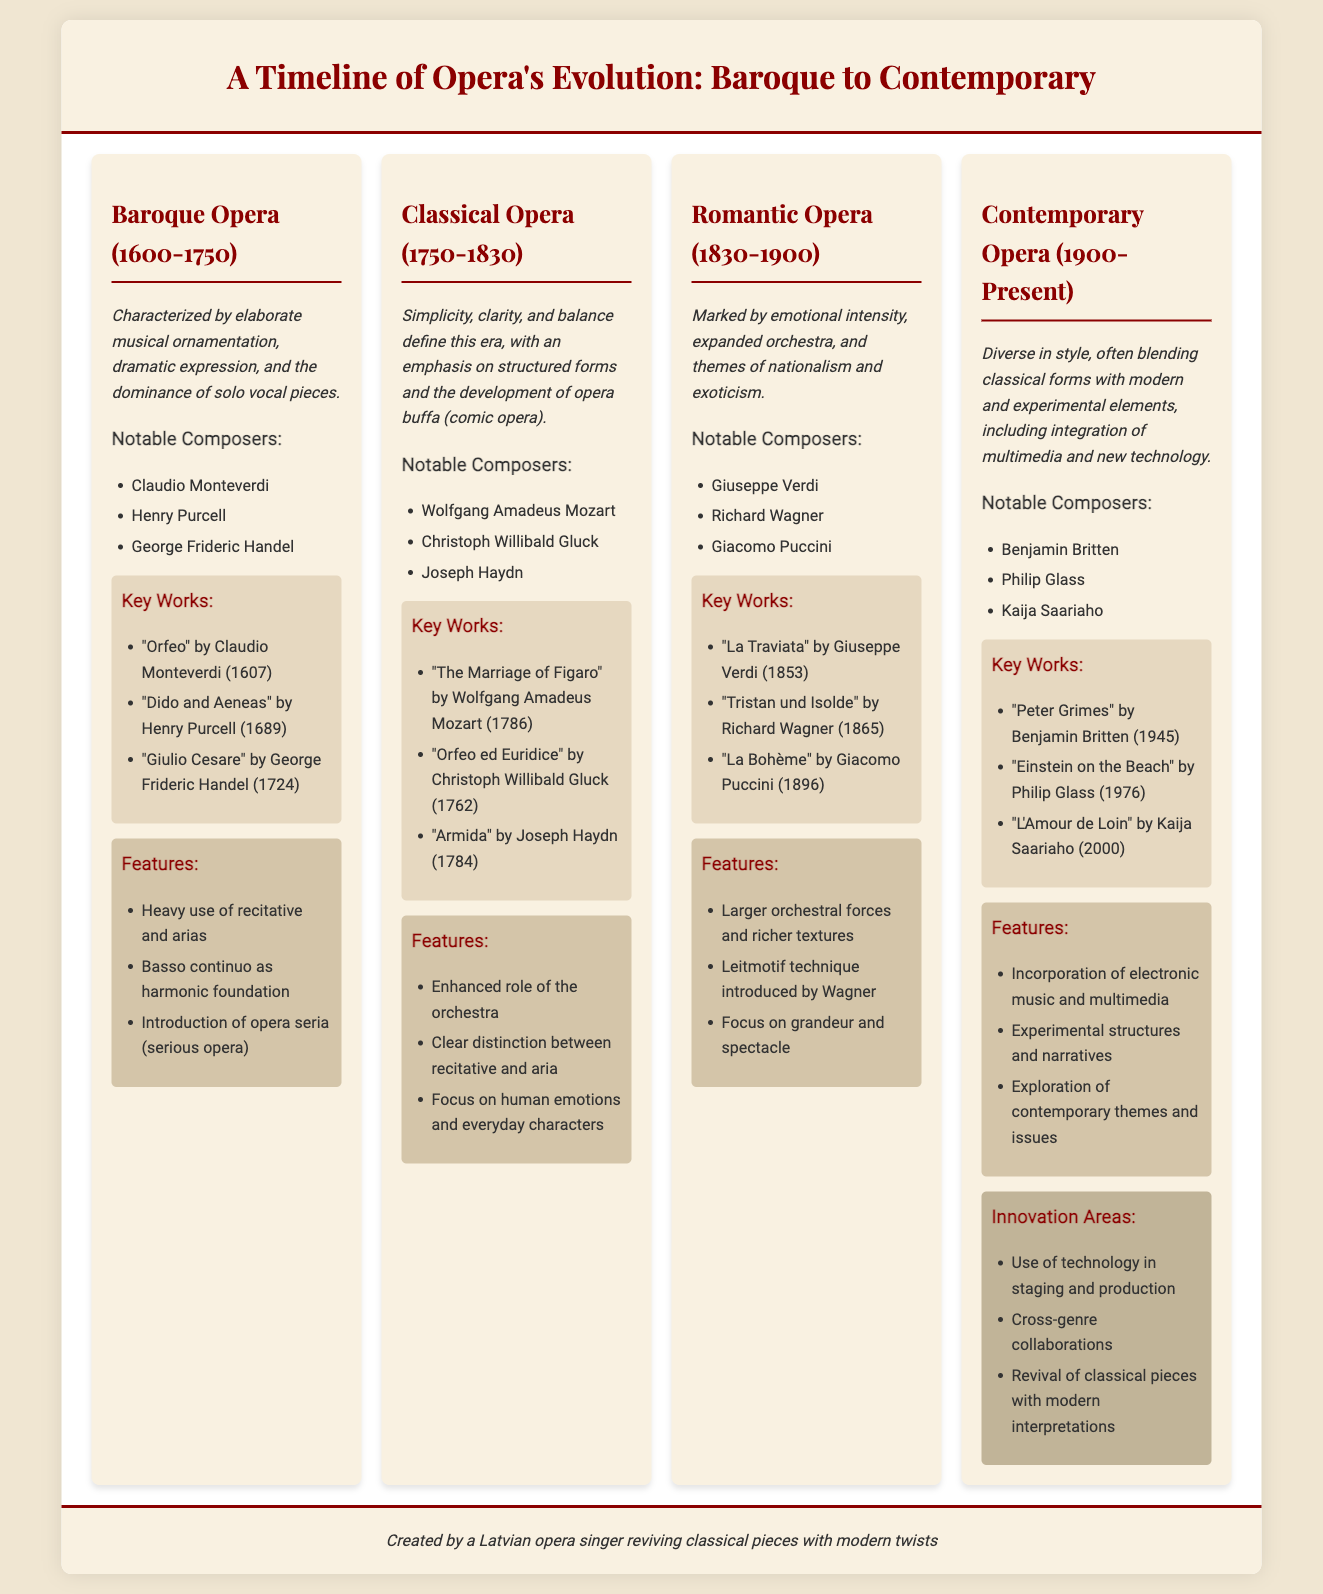What are the years of the Baroque Opera era? The Baroque Opera era is defined by the years 1600 to 1750 as stated in the document.
Answer: 1600-1750 Who composed "La Traviata"? "La Traviata" is attributed to Giuseppe Verdi according to the key works listed in the document.
Answer: Giuseppe Verdi Which style is characterized by emotional intensity and themes of nationalism? The Romantic Opera era is marked by emotional intensity and themes of nationalism as described in the document.
Answer: Romantic Opera What notable composer is associated with the Contemporary Opera era? William Philip Glass is listed as a notable composer for the Contemporary Opera era in the document.
Answer: Philip Glass How many key works are listed for Classical Opera? There are three key works mentioned for the Classical Opera era, which can be counted from the key works section.
Answer: 3 Which innovation areas are mentioned in the Contemporary Opera section? The innovation areas include technology use in staging, cross-genre collaborations, and revival of classical pieces as highlighted in the document.
Answer: Technology use, cross-genre collaborations, revival of classical pieces What is the main feature of Baroque Opera? The main features of the Baroque Opera era include heavy use of recitative and arias, as noted in the features section.
Answer: Heavy use of recitative and arias Which piece did Christoph Willibald Gluck compose? "Orfeo ed Euridice" is the work composed by Christoph Willibald Gluck according to the key works listed.
Answer: "Orfeo ed Euridice" What does the document suggest about innovation in Contemporary Opera? The document suggests that Contemporary Opera involves revival of classical pieces with modern interpretations as part of its innovation areas.
Answer: Revival of classical pieces with modern interpretations 